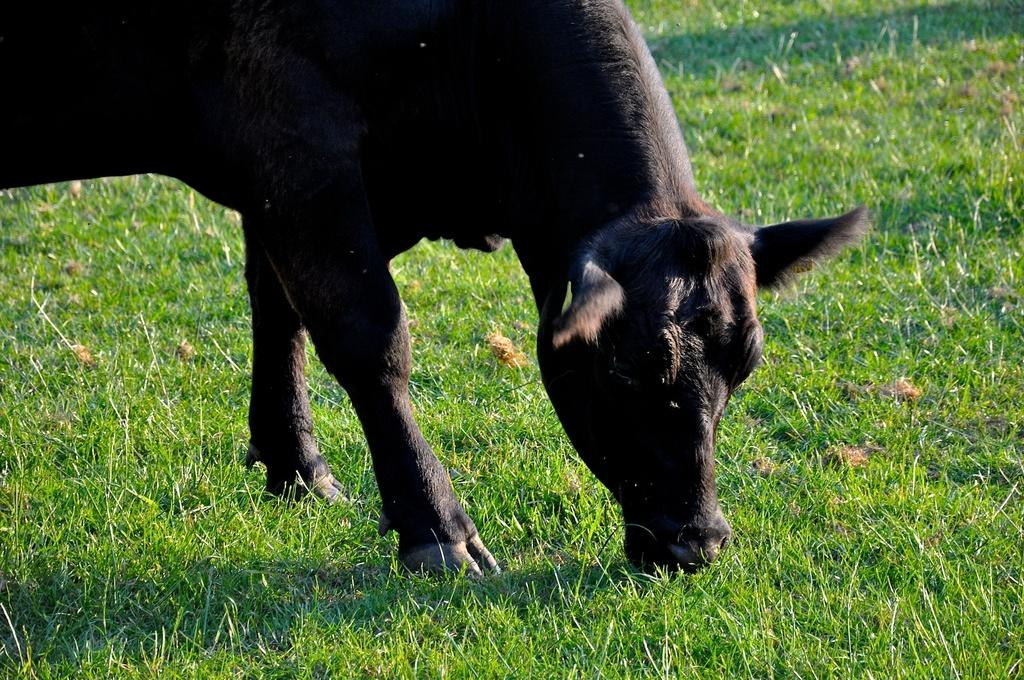What type of animal can be seen in the image? There is a black color animal in the image. What is the position of the animal in the image? The animal is standing. What type of vegetation is visible in the image? There is grass visible in the image. What is the purpose of the horn on the animal in the image? There is no horn present on the animal in the image. 